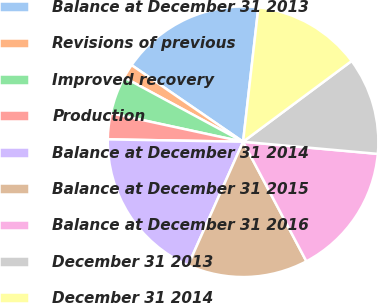Convert chart to OTSL. <chart><loc_0><loc_0><loc_500><loc_500><pie_chart><fcel>Balance at December 31 2013<fcel>Revisions of previous<fcel>Improved recovery<fcel>Production<fcel>Balance at December 31 2014<fcel>Balance at December 31 2015<fcel>Balance at December 31 2016<fcel>December 31 2013<fcel>December 31 2014<nl><fcel>17.22%<fcel>1.7%<fcel>4.5%<fcel>3.1%<fcel>18.62%<fcel>14.41%<fcel>15.82%<fcel>11.61%<fcel>13.01%<nl></chart> 